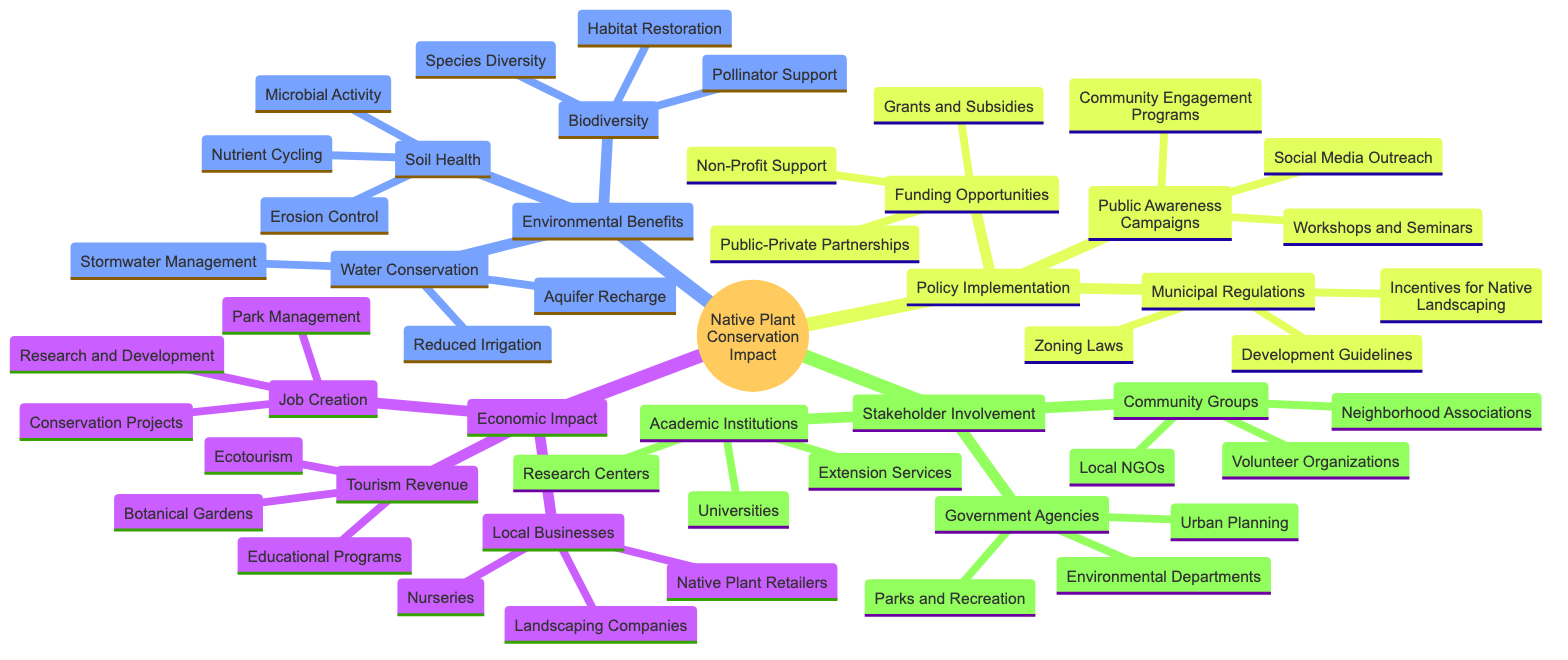What are the three main categories in the mind map? The main categories displayed in the mind map are "Economic Impact," "Environmental Benefits," and "Policy Implementation." Each serves as a primary division in assessing the overall impact of native plant conservation.
Answer: Economic Impact, Environmental Benefits, Policy Implementation How many sub-components are there under Local Businesses? Under the "Local Businesses" node, there are three sub-components: Nurseries, Landscaping Companies, and Native Plant Retailers, which indicate the sectors that may economically benefit from native plant conservation.
Answer: 3 What is a benefit of Biodiversity provided in the map? The benefits detailed under "Biodiversity" include Habitat Restoration, Pollinator Support, and Species Diversity. These elements highlight how biodiversity enhances ecosystem resilience.
Answer: Habitat Restoration Which category has the most sub-components? The "Environmental Benefits" category has three sub-components: Biodiversity, Soil Health, and Water Conservation, each containing additional detailed aspects. Each of these main environmental areas contributes significantly to the overall impact assessment.
Answer: Environmental Benefits What is one method of water conservation listed? One specific method shown under the "Water Conservation" node is "Reduced Irrigation," which indicates strategies to lessen water usage in landscaping with native plants.
Answer: Reduced Irrigation Which two groups are part of Stakeholder Involvement? The two groups mentioned in the "Stakeholder Involvement" portion of the mind map are Community Groups and Government Agencies, signifying important social actors in the conservation policy process.
Answer: Community Groups, Government Agencies How many components are there under Policy Implementation? There are three components in the "Policy Implementation" category: Municipal Regulations, Public Awareness Campaigns, and Funding Opportunities, showing diverse pathways to effective policy execution.
Answer: 3 Which aspect relates to job creation in this mind map? "Job Creation" is specifically linked to Conservation Projects, Park Management, and Research and Development, indicating economic opportunities arising directly from the conservation of native plants.
Answer: Conservation Projects What is the focus of Public Awareness Campaigns? The focus of "Public Awareness Campaigns" includes Workshops and Seminars, Social Media Outreach, and Community Engagement Programs, emphasizing the necessity of informing the public about conservation efforts.
Answer: Workshops and Seminars 